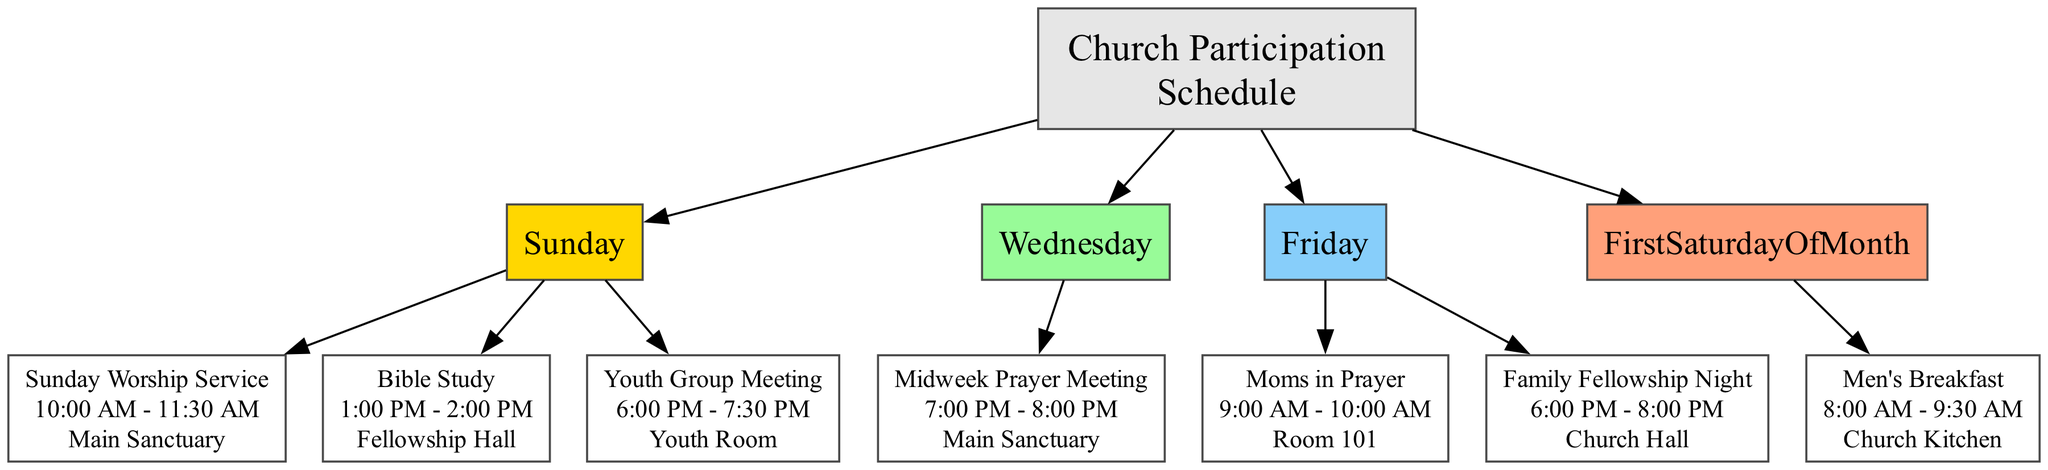What is the main activity on Sunday morning? The diagram shows that the main activity on Sunday morning is labeled as "Sunday Worship Service". This information can be found directly under the Sunday node and indicates what takes place at that time.
Answer: Sunday Worship Service What time does the Bible Study occur on Sunday? The diagram specifies that the Bible Study event occurs from 1:00 PM to 2:00 PM under the Sunday node. This can be directly observed from the information associated with the Bible Study time of day.
Answer: 1:00 PM - 2:00 PM How many activities are scheduled on Wednesday? According to the diagram, there is only one scheduled activity on Wednesday, which is the Midweek Prayer Meeting. By counting the activities listed under the Wednesday node, we find that there is one entry.
Answer: 1 Where is the Men's Breakfast held? The diagram clearly states that the Men's Breakfast is located in the Church Kitchen. This information is listed under the First Saturday of the Month node, providing location details for that activity.
Answer: Church Kitchen What is the duration of the Family Fellowship Night event? The Family Fellowship Night event runs from 6:00 PM to 8:00 PM, making it a two-hour duration. By checking the time indicated under the Friday Evening activity, we calculate the difference between the start and end times.
Answer: 2 hours What is the only activity that occurs on Friday morning? The only activity listed for Friday morning is "Moms in Prayer". This can be directly identified under the Friday node, in the Morning segment.
Answer: Moms in Prayer On which day do the Youth Group Meetings take place? The diagram indicates that Youth Group Meetings are scheduled for Sunday evening. By checking the activities listed under the Sunday node, we can see that this meeting is specifically noted there.
Answer: Sunday Which activity follows the Sunday Worship Service? The activity that follows the Sunday Worship Service, based on the schedule, is the Bible Study at 1:00 PM. This sequence can be deduced by observing the activities scheduled on Sunday in chronological order.
Answer: Bible Study 